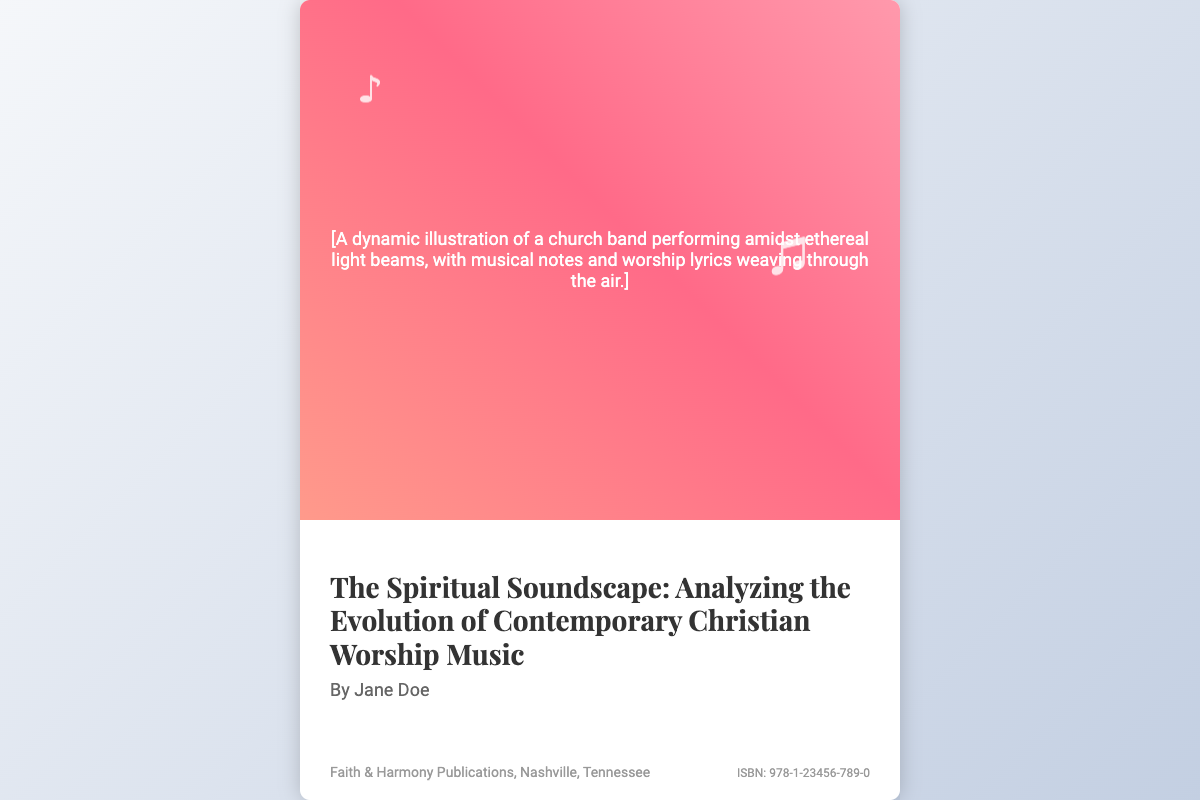What is the title of the book? The title of the book is prominently displayed in a large font.
Answer: The Spiritual Soundscape: Analyzing the Evolution of Contemporary Christian Worship Music Who is the author of the book? The author's name is listed directly under the title of the book.
Answer: Jane Doe What is the name of the publisher? The publisher's information is provided at the bottom of the cover.
Answer: Faith & Harmony Publications What city is the publisher located in? The location of the publisher is included below the author's name.
Answer: Nashville, Tennessee What is the ISBN of the book? The ISBN is stated in the information section at the bottom right of the cover.
Answer: 978-1-23456-789-0 What colors are used in the background of the book cover? The background consists of a gradient blending specific colors.
Answer: #f5f7fa and #c3cfe2 What type of illustration is on the cover? The illustration's description specifies the type and atmosphere.
Answer: A church band performing amidst ethereal light beams How does the music note appear on the cover? The music notes are animated to create a dynamic effect on the cover.
Answer: Floating What themes does the book likely address? The themes can be inferred from the title and subject matter depicted.
Answer: Contemporary Christian worship music 